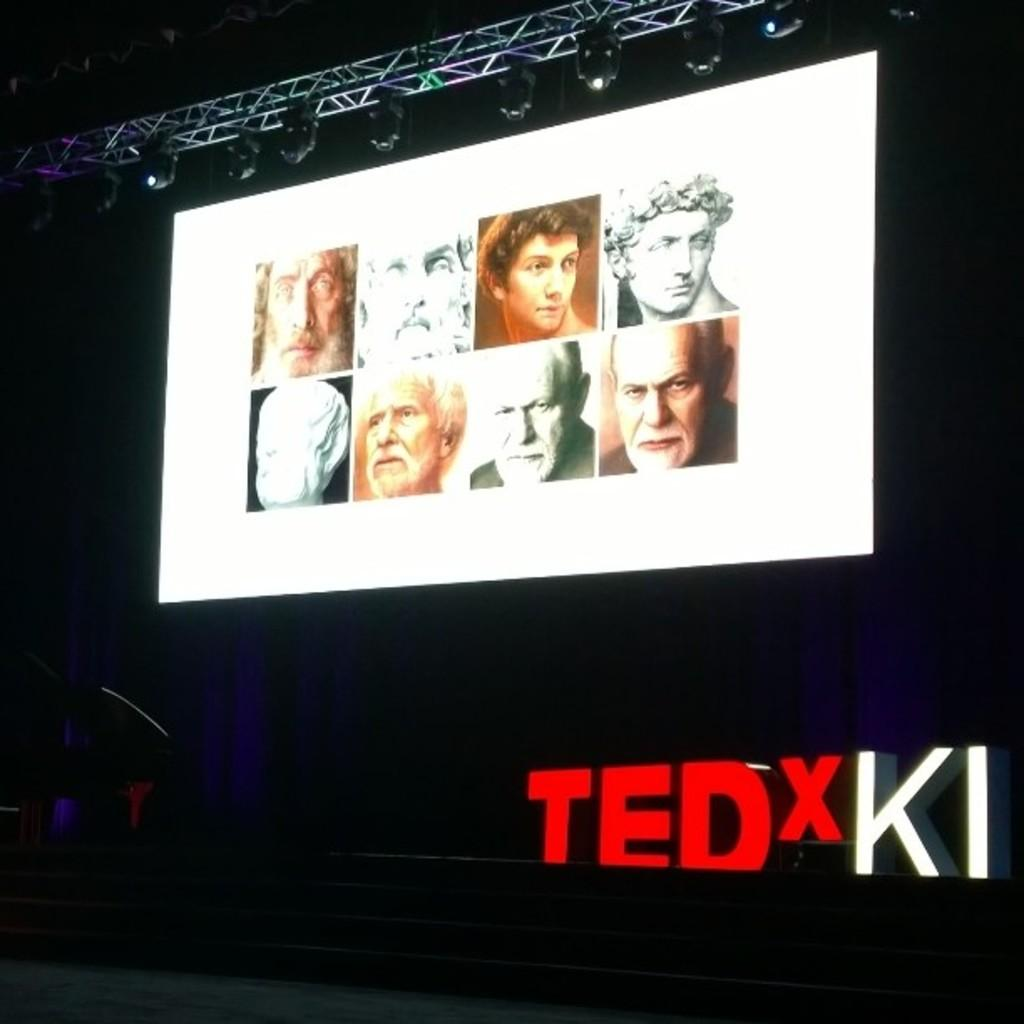What is the main feature on the stage in the image? There is a screen on the stage in the image. What is shown on the screen? The screen displays photos of people. Is there any additional information provided with the photos? Yes, there is some text underneath the photos on the screen. What color is the dress worn by the kitten in the image? There is no kitten or dress present in the image; it features a screen displaying photos of people with text underneath. 